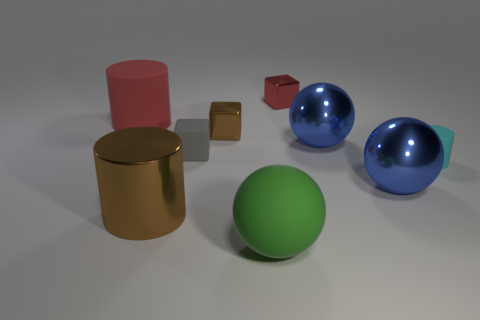Can we infer anything about the lighting in this scene? The lighting in the scene is diffused, creating soft shadows under the objects. There is a primary light source coming from the upper left direction, as indicated by the highlights and the direction of shadows. This diffuse lighting suggests an overcast sky or an indoor environment with well-spread illuminance. Does the lighting affect the color perception of the objects? Yes, the lighting can significantly affect how we perceive colors. In this image, the soft, even lighting allows the colors to appear true to their hue without harsh shadows distorting the perception. However, the varying levels of glossiness on the objects can make areas of the color appear lighter or darker depending on the light reflections. 